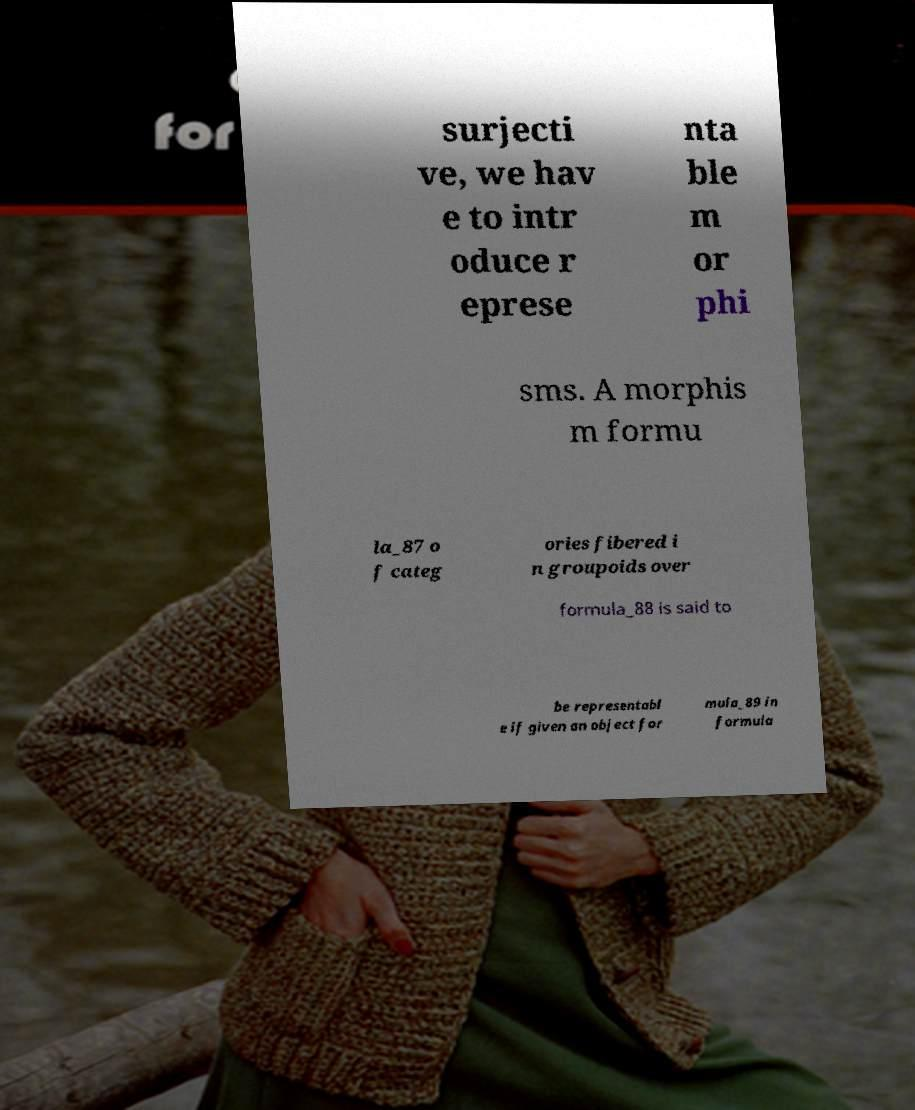Can you accurately transcribe the text from the provided image for me? surjecti ve, we hav e to intr oduce r eprese nta ble m or phi sms. A morphis m formu la_87 o f categ ories fibered i n groupoids over formula_88 is said to be representabl e if given an object for mula_89 in formula 